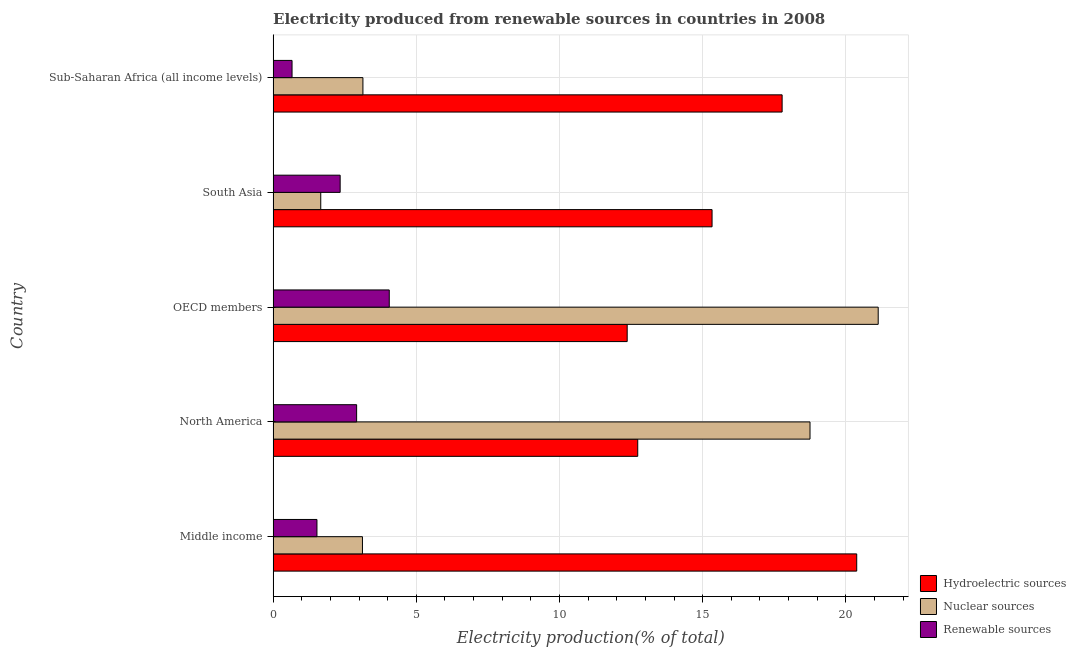How many different coloured bars are there?
Your answer should be very brief. 3. Are the number of bars on each tick of the Y-axis equal?
Offer a terse response. Yes. What is the percentage of electricity produced by nuclear sources in Sub-Saharan Africa (all income levels)?
Offer a terse response. 3.14. Across all countries, what is the maximum percentage of electricity produced by nuclear sources?
Keep it short and to the point. 21.13. Across all countries, what is the minimum percentage of electricity produced by renewable sources?
Offer a terse response. 0.66. What is the total percentage of electricity produced by renewable sources in the graph?
Provide a short and direct response. 11.51. What is the difference between the percentage of electricity produced by nuclear sources in Middle income and that in OECD members?
Your answer should be compact. -18.01. What is the difference between the percentage of electricity produced by nuclear sources in Middle income and the percentage of electricity produced by hydroelectric sources in Sub-Saharan Africa (all income levels)?
Your answer should be compact. -14.66. What is the average percentage of electricity produced by renewable sources per country?
Ensure brevity in your answer.  2.3. What is the difference between the percentage of electricity produced by hydroelectric sources and percentage of electricity produced by renewable sources in Middle income?
Give a very brief answer. 18.85. What is the ratio of the percentage of electricity produced by nuclear sources in North America to that in Sub-Saharan Africa (all income levels)?
Your response must be concise. 5.98. Is the percentage of electricity produced by nuclear sources in OECD members less than that in Sub-Saharan Africa (all income levels)?
Offer a terse response. No. Is the difference between the percentage of electricity produced by nuclear sources in OECD members and Sub-Saharan Africa (all income levels) greater than the difference between the percentage of electricity produced by renewable sources in OECD members and Sub-Saharan Africa (all income levels)?
Offer a very short reply. Yes. What is the difference between the highest and the second highest percentage of electricity produced by nuclear sources?
Provide a succinct answer. 2.38. Is the sum of the percentage of electricity produced by nuclear sources in Middle income and South Asia greater than the maximum percentage of electricity produced by hydroelectric sources across all countries?
Keep it short and to the point. No. What does the 1st bar from the top in Sub-Saharan Africa (all income levels) represents?
Give a very brief answer. Renewable sources. What does the 1st bar from the bottom in South Asia represents?
Provide a short and direct response. Hydroelectric sources. Is it the case that in every country, the sum of the percentage of electricity produced by hydroelectric sources and percentage of electricity produced by nuclear sources is greater than the percentage of electricity produced by renewable sources?
Offer a terse response. Yes. How many bars are there?
Provide a succinct answer. 15. What is the difference between two consecutive major ticks on the X-axis?
Provide a short and direct response. 5. Are the values on the major ticks of X-axis written in scientific E-notation?
Provide a succinct answer. No. Does the graph contain any zero values?
Provide a succinct answer. No. How many legend labels are there?
Make the answer very short. 3. How are the legend labels stacked?
Offer a terse response. Vertical. What is the title of the graph?
Your answer should be very brief. Electricity produced from renewable sources in countries in 2008. What is the label or title of the X-axis?
Make the answer very short. Electricity production(% of total). What is the label or title of the Y-axis?
Make the answer very short. Country. What is the Electricity production(% of total) in Hydroelectric sources in Middle income?
Your answer should be compact. 20.38. What is the Electricity production(% of total) of Nuclear sources in Middle income?
Offer a very short reply. 3.12. What is the Electricity production(% of total) of Renewable sources in Middle income?
Ensure brevity in your answer.  1.53. What is the Electricity production(% of total) of Hydroelectric sources in North America?
Offer a terse response. 12.73. What is the Electricity production(% of total) in Nuclear sources in North America?
Your response must be concise. 18.75. What is the Electricity production(% of total) of Renewable sources in North America?
Provide a short and direct response. 2.92. What is the Electricity production(% of total) of Hydroelectric sources in OECD members?
Offer a very short reply. 12.37. What is the Electricity production(% of total) of Nuclear sources in OECD members?
Your response must be concise. 21.13. What is the Electricity production(% of total) of Renewable sources in OECD members?
Offer a terse response. 4.06. What is the Electricity production(% of total) in Hydroelectric sources in South Asia?
Your answer should be very brief. 15.33. What is the Electricity production(% of total) of Nuclear sources in South Asia?
Offer a terse response. 1.66. What is the Electricity production(% of total) in Renewable sources in South Asia?
Your response must be concise. 2.34. What is the Electricity production(% of total) in Hydroelectric sources in Sub-Saharan Africa (all income levels)?
Your answer should be very brief. 17.78. What is the Electricity production(% of total) of Nuclear sources in Sub-Saharan Africa (all income levels)?
Make the answer very short. 3.14. What is the Electricity production(% of total) of Renewable sources in Sub-Saharan Africa (all income levels)?
Your answer should be compact. 0.66. Across all countries, what is the maximum Electricity production(% of total) of Hydroelectric sources?
Ensure brevity in your answer.  20.38. Across all countries, what is the maximum Electricity production(% of total) in Nuclear sources?
Your answer should be compact. 21.13. Across all countries, what is the maximum Electricity production(% of total) of Renewable sources?
Your answer should be compact. 4.06. Across all countries, what is the minimum Electricity production(% of total) in Hydroelectric sources?
Your answer should be compact. 12.37. Across all countries, what is the minimum Electricity production(% of total) in Nuclear sources?
Your response must be concise. 1.66. Across all countries, what is the minimum Electricity production(% of total) of Renewable sources?
Your response must be concise. 0.66. What is the total Electricity production(% of total) of Hydroelectric sources in the graph?
Keep it short and to the point. 78.58. What is the total Electricity production(% of total) in Nuclear sources in the graph?
Make the answer very short. 47.8. What is the total Electricity production(% of total) of Renewable sources in the graph?
Ensure brevity in your answer.  11.51. What is the difference between the Electricity production(% of total) in Hydroelectric sources in Middle income and that in North America?
Provide a short and direct response. 7.65. What is the difference between the Electricity production(% of total) in Nuclear sources in Middle income and that in North America?
Keep it short and to the point. -15.63. What is the difference between the Electricity production(% of total) in Renewable sources in Middle income and that in North America?
Make the answer very short. -1.39. What is the difference between the Electricity production(% of total) of Hydroelectric sources in Middle income and that in OECD members?
Offer a terse response. 8.02. What is the difference between the Electricity production(% of total) of Nuclear sources in Middle income and that in OECD members?
Provide a succinct answer. -18.01. What is the difference between the Electricity production(% of total) in Renewable sources in Middle income and that in OECD members?
Ensure brevity in your answer.  -2.53. What is the difference between the Electricity production(% of total) of Hydroelectric sources in Middle income and that in South Asia?
Ensure brevity in your answer.  5.05. What is the difference between the Electricity production(% of total) of Nuclear sources in Middle income and that in South Asia?
Offer a very short reply. 1.46. What is the difference between the Electricity production(% of total) in Renewable sources in Middle income and that in South Asia?
Your answer should be compact. -0.81. What is the difference between the Electricity production(% of total) in Hydroelectric sources in Middle income and that in Sub-Saharan Africa (all income levels)?
Ensure brevity in your answer.  2.6. What is the difference between the Electricity production(% of total) of Nuclear sources in Middle income and that in Sub-Saharan Africa (all income levels)?
Provide a short and direct response. -0.02. What is the difference between the Electricity production(% of total) of Renewable sources in Middle income and that in Sub-Saharan Africa (all income levels)?
Provide a short and direct response. 0.87. What is the difference between the Electricity production(% of total) of Hydroelectric sources in North America and that in OECD members?
Your answer should be very brief. 0.37. What is the difference between the Electricity production(% of total) of Nuclear sources in North America and that in OECD members?
Give a very brief answer. -2.38. What is the difference between the Electricity production(% of total) in Renewable sources in North America and that in OECD members?
Offer a terse response. -1.14. What is the difference between the Electricity production(% of total) of Hydroelectric sources in North America and that in South Asia?
Ensure brevity in your answer.  -2.6. What is the difference between the Electricity production(% of total) of Nuclear sources in North America and that in South Asia?
Your answer should be compact. 17.09. What is the difference between the Electricity production(% of total) of Renewable sources in North America and that in South Asia?
Your answer should be very brief. 0.58. What is the difference between the Electricity production(% of total) of Hydroelectric sources in North America and that in Sub-Saharan Africa (all income levels)?
Provide a succinct answer. -5.04. What is the difference between the Electricity production(% of total) of Nuclear sources in North America and that in Sub-Saharan Africa (all income levels)?
Keep it short and to the point. 15.61. What is the difference between the Electricity production(% of total) in Renewable sources in North America and that in Sub-Saharan Africa (all income levels)?
Your answer should be compact. 2.26. What is the difference between the Electricity production(% of total) of Hydroelectric sources in OECD members and that in South Asia?
Offer a very short reply. -2.96. What is the difference between the Electricity production(% of total) in Nuclear sources in OECD members and that in South Asia?
Your response must be concise. 19.47. What is the difference between the Electricity production(% of total) in Renewable sources in OECD members and that in South Asia?
Give a very brief answer. 1.72. What is the difference between the Electricity production(% of total) in Hydroelectric sources in OECD members and that in Sub-Saharan Africa (all income levels)?
Your response must be concise. -5.41. What is the difference between the Electricity production(% of total) of Nuclear sources in OECD members and that in Sub-Saharan Africa (all income levels)?
Your answer should be very brief. 18. What is the difference between the Electricity production(% of total) of Renewable sources in OECD members and that in Sub-Saharan Africa (all income levels)?
Your answer should be compact. 3.4. What is the difference between the Electricity production(% of total) of Hydroelectric sources in South Asia and that in Sub-Saharan Africa (all income levels)?
Offer a terse response. -2.45. What is the difference between the Electricity production(% of total) of Nuclear sources in South Asia and that in Sub-Saharan Africa (all income levels)?
Provide a succinct answer. -1.47. What is the difference between the Electricity production(% of total) of Renewable sources in South Asia and that in Sub-Saharan Africa (all income levels)?
Provide a short and direct response. 1.68. What is the difference between the Electricity production(% of total) of Hydroelectric sources in Middle income and the Electricity production(% of total) of Nuclear sources in North America?
Give a very brief answer. 1.63. What is the difference between the Electricity production(% of total) of Hydroelectric sources in Middle income and the Electricity production(% of total) of Renewable sources in North America?
Provide a succinct answer. 17.46. What is the difference between the Electricity production(% of total) of Nuclear sources in Middle income and the Electricity production(% of total) of Renewable sources in North America?
Offer a very short reply. 0.2. What is the difference between the Electricity production(% of total) in Hydroelectric sources in Middle income and the Electricity production(% of total) in Nuclear sources in OECD members?
Offer a very short reply. -0.75. What is the difference between the Electricity production(% of total) in Hydroelectric sources in Middle income and the Electricity production(% of total) in Renewable sources in OECD members?
Provide a short and direct response. 16.32. What is the difference between the Electricity production(% of total) of Nuclear sources in Middle income and the Electricity production(% of total) of Renewable sources in OECD members?
Give a very brief answer. -0.94. What is the difference between the Electricity production(% of total) of Hydroelectric sources in Middle income and the Electricity production(% of total) of Nuclear sources in South Asia?
Your answer should be compact. 18.72. What is the difference between the Electricity production(% of total) of Hydroelectric sources in Middle income and the Electricity production(% of total) of Renewable sources in South Asia?
Ensure brevity in your answer.  18.04. What is the difference between the Electricity production(% of total) in Nuclear sources in Middle income and the Electricity production(% of total) in Renewable sources in South Asia?
Your answer should be compact. 0.78. What is the difference between the Electricity production(% of total) of Hydroelectric sources in Middle income and the Electricity production(% of total) of Nuclear sources in Sub-Saharan Africa (all income levels)?
Ensure brevity in your answer.  17.24. What is the difference between the Electricity production(% of total) in Hydroelectric sources in Middle income and the Electricity production(% of total) in Renewable sources in Sub-Saharan Africa (all income levels)?
Your response must be concise. 19.72. What is the difference between the Electricity production(% of total) in Nuclear sources in Middle income and the Electricity production(% of total) in Renewable sources in Sub-Saharan Africa (all income levels)?
Offer a terse response. 2.46. What is the difference between the Electricity production(% of total) of Hydroelectric sources in North America and the Electricity production(% of total) of Nuclear sources in OECD members?
Keep it short and to the point. -8.4. What is the difference between the Electricity production(% of total) of Hydroelectric sources in North America and the Electricity production(% of total) of Renewable sources in OECD members?
Ensure brevity in your answer.  8.68. What is the difference between the Electricity production(% of total) in Nuclear sources in North America and the Electricity production(% of total) in Renewable sources in OECD members?
Your answer should be very brief. 14.69. What is the difference between the Electricity production(% of total) in Hydroelectric sources in North America and the Electricity production(% of total) in Nuclear sources in South Asia?
Give a very brief answer. 11.07. What is the difference between the Electricity production(% of total) in Hydroelectric sources in North America and the Electricity production(% of total) in Renewable sources in South Asia?
Your answer should be compact. 10.39. What is the difference between the Electricity production(% of total) of Nuclear sources in North America and the Electricity production(% of total) of Renewable sources in South Asia?
Provide a short and direct response. 16.41. What is the difference between the Electricity production(% of total) of Hydroelectric sources in North America and the Electricity production(% of total) of Nuclear sources in Sub-Saharan Africa (all income levels)?
Your response must be concise. 9.6. What is the difference between the Electricity production(% of total) in Hydroelectric sources in North America and the Electricity production(% of total) in Renewable sources in Sub-Saharan Africa (all income levels)?
Offer a terse response. 12.07. What is the difference between the Electricity production(% of total) of Nuclear sources in North America and the Electricity production(% of total) of Renewable sources in Sub-Saharan Africa (all income levels)?
Offer a very short reply. 18.09. What is the difference between the Electricity production(% of total) in Hydroelectric sources in OECD members and the Electricity production(% of total) in Nuclear sources in South Asia?
Your answer should be compact. 10.7. What is the difference between the Electricity production(% of total) of Hydroelectric sources in OECD members and the Electricity production(% of total) of Renewable sources in South Asia?
Offer a terse response. 10.02. What is the difference between the Electricity production(% of total) in Nuclear sources in OECD members and the Electricity production(% of total) in Renewable sources in South Asia?
Provide a short and direct response. 18.79. What is the difference between the Electricity production(% of total) in Hydroelectric sources in OECD members and the Electricity production(% of total) in Nuclear sources in Sub-Saharan Africa (all income levels)?
Your answer should be compact. 9.23. What is the difference between the Electricity production(% of total) of Hydroelectric sources in OECD members and the Electricity production(% of total) of Renewable sources in Sub-Saharan Africa (all income levels)?
Your response must be concise. 11.7. What is the difference between the Electricity production(% of total) in Nuclear sources in OECD members and the Electricity production(% of total) in Renewable sources in Sub-Saharan Africa (all income levels)?
Provide a short and direct response. 20.47. What is the difference between the Electricity production(% of total) in Hydroelectric sources in South Asia and the Electricity production(% of total) in Nuclear sources in Sub-Saharan Africa (all income levels)?
Offer a terse response. 12.19. What is the difference between the Electricity production(% of total) in Hydroelectric sources in South Asia and the Electricity production(% of total) in Renewable sources in Sub-Saharan Africa (all income levels)?
Your response must be concise. 14.67. What is the difference between the Electricity production(% of total) in Nuclear sources in South Asia and the Electricity production(% of total) in Renewable sources in Sub-Saharan Africa (all income levels)?
Offer a very short reply. 1. What is the average Electricity production(% of total) in Hydroelectric sources per country?
Ensure brevity in your answer.  15.72. What is the average Electricity production(% of total) in Nuclear sources per country?
Your answer should be compact. 9.56. What is the average Electricity production(% of total) of Renewable sources per country?
Keep it short and to the point. 2.3. What is the difference between the Electricity production(% of total) of Hydroelectric sources and Electricity production(% of total) of Nuclear sources in Middle income?
Offer a very short reply. 17.26. What is the difference between the Electricity production(% of total) in Hydroelectric sources and Electricity production(% of total) in Renewable sources in Middle income?
Make the answer very short. 18.85. What is the difference between the Electricity production(% of total) in Nuclear sources and Electricity production(% of total) in Renewable sources in Middle income?
Your response must be concise. 1.59. What is the difference between the Electricity production(% of total) in Hydroelectric sources and Electricity production(% of total) in Nuclear sources in North America?
Offer a very short reply. -6.02. What is the difference between the Electricity production(% of total) of Hydroelectric sources and Electricity production(% of total) of Renewable sources in North America?
Offer a terse response. 9.82. What is the difference between the Electricity production(% of total) in Nuclear sources and Electricity production(% of total) in Renewable sources in North America?
Offer a very short reply. 15.83. What is the difference between the Electricity production(% of total) of Hydroelectric sources and Electricity production(% of total) of Nuclear sources in OECD members?
Your answer should be compact. -8.77. What is the difference between the Electricity production(% of total) of Hydroelectric sources and Electricity production(% of total) of Renewable sources in OECD members?
Offer a very short reply. 8.31. What is the difference between the Electricity production(% of total) of Nuclear sources and Electricity production(% of total) of Renewable sources in OECD members?
Offer a very short reply. 17.08. What is the difference between the Electricity production(% of total) in Hydroelectric sources and Electricity production(% of total) in Nuclear sources in South Asia?
Make the answer very short. 13.67. What is the difference between the Electricity production(% of total) in Hydroelectric sources and Electricity production(% of total) in Renewable sources in South Asia?
Ensure brevity in your answer.  12.99. What is the difference between the Electricity production(% of total) in Nuclear sources and Electricity production(% of total) in Renewable sources in South Asia?
Make the answer very short. -0.68. What is the difference between the Electricity production(% of total) of Hydroelectric sources and Electricity production(% of total) of Nuclear sources in Sub-Saharan Africa (all income levels)?
Keep it short and to the point. 14.64. What is the difference between the Electricity production(% of total) of Hydroelectric sources and Electricity production(% of total) of Renewable sources in Sub-Saharan Africa (all income levels)?
Provide a succinct answer. 17.11. What is the difference between the Electricity production(% of total) of Nuclear sources and Electricity production(% of total) of Renewable sources in Sub-Saharan Africa (all income levels)?
Offer a terse response. 2.48. What is the ratio of the Electricity production(% of total) in Hydroelectric sources in Middle income to that in North America?
Make the answer very short. 1.6. What is the ratio of the Electricity production(% of total) of Nuclear sources in Middle income to that in North America?
Provide a succinct answer. 0.17. What is the ratio of the Electricity production(% of total) in Renewable sources in Middle income to that in North America?
Offer a terse response. 0.53. What is the ratio of the Electricity production(% of total) of Hydroelectric sources in Middle income to that in OECD members?
Provide a short and direct response. 1.65. What is the ratio of the Electricity production(% of total) in Nuclear sources in Middle income to that in OECD members?
Your response must be concise. 0.15. What is the ratio of the Electricity production(% of total) in Renewable sources in Middle income to that in OECD members?
Make the answer very short. 0.38. What is the ratio of the Electricity production(% of total) of Hydroelectric sources in Middle income to that in South Asia?
Make the answer very short. 1.33. What is the ratio of the Electricity production(% of total) of Nuclear sources in Middle income to that in South Asia?
Your answer should be very brief. 1.88. What is the ratio of the Electricity production(% of total) of Renewable sources in Middle income to that in South Asia?
Your answer should be very brief. 0.65. What is the ratio of the Electricity production(% of total) in Hydroelectric sources in Middle income to that in Sub-Saharan Africa (all income levels)?
Provide a succinct answer. 1.15. What is the ratio of the Electricity production(% of total) of Nuclear sources in Middle income to that in Sub-Saharan Africa (all income levels)?
Ensure brevity in your answer.  0.99. What is the ratio of the Electricity production(% of total) of Renewable sources in Middle income to that in Sub-Saharan Africa (all income levels)?
Your response must be concise. 2.32. What is the ratio of the Electricity production(% of total) of Hydroelectric sources in North America to that in OECD members?
Your answer should be very brief. 1.03. What is the ratio of the Electricity production(% of total) of Nuclear sources in North America to that in OECD members?
Your response must be concise. 0.89. What is the ratio of the Electricity production(% of total) in Renewable sources in North America to that in OECD members?
Provide a short and direct response. 0.72. What is the ratio of the Electricity production(% of total) of Hydroelectric sources in North America to that in South Asia?
Offer a terse response. 0.83. What is the ratio of the Electricity production(% of total) of Nuclear sources in North America to that in South Asia?
Your answer should be compact. 11.27. What is the ratio of the Electricity production(% of total) in Renewable sources in North America to that in South Asia?
Provide a short and direct response. 1.25. What is the ratio of the Electricity production(% of total) of Hydroelectric sources in North America to that in Sub-Saharan Africa (all income levels)?
Ensure brevity in your answer.  0.72. What is the ratio of the Electricity production(% of total) in Nuclear sources in North America to that in Sub-Saharan Africa (all income levels)?
Your answer should be compact. 5.98. What is the ratio of the Electricity production(% of total) in Renewable sources in North America to that in Sub-Saharan Africa (all income levels)?
Make the answer very short. 4.41. What is the ratio of the Electricity production(% of total) in Hydroelectric sources in OECD members to that in South Asia?
Provide a succinct answer. 0.81. What is the ratio of the Electricity production(% of total) in Nuclear sources in OECD members to that in South Asia?
Ensure brevity in your answer.  12.7. What is the ratio of the Electricity production(% of total) in Renewable sources in OECD members to that in South Asia?
Provide a short and direct response. 1.73. What is the ratio of the Electricity production(% of total) in Hydroelectric sources in OECD members to that in Sub-Saharan Africa (all income levels)?
Keep it short and to the point. 0.7. What is the ratio of the Electricity production(% of total) in Nuclear sources in OECD members to that in Sub-Saharan Africa (all income levels)?
Give a very brief answer. 6.74. What is the ratio of the Electricity production(% of total) in Renewable sources in OECD members to that in Sub-Saharan Africa (all income levels)?
Give a very brief answer. 6.14. What is the ratio of the Electricity production(% of total) of Hydroelectric sources in South Asia to that in Sub-Saharan Africa (all income levels)?
Provide a succinct answer. 0.86. What is the ratio of the Electricity production(% of total) in Nuclear sources in South Asia to that in Sub-Saharan Africa (all income levels)?
Give a very brief answer. 0.53. What is the ratio of the Electricity production(% of total) of Renewable sources in South Asia to that in Sub-Saharan Africa (all income levels)?
Your answer should be compact. 3.54. What is the difference between the highest and the second highest Electricity production(% of total) in Hydroelectric sources?
Ensure brevity in your answer.  2.6. What is the difference between the highest and the second highest Electricity production(% of total) of Nuclear sources?
Offer a very short reply. 2.38. What is the difference between the highest and the second highest Electricity production(% of total) of Renewable sources?
Provide a succinct answer. 1.14. What is the difference between the highest and the lowest Electricity production(% of total) in Hydroelectric sources?
Provide a short and direct response. 8.02. What is the difference between the highest and the lowest Electricity production(% of total) in Nuclear sources?
Your answer should be compact. 19.47. What is the difference between the highest and the lowest Electricity production(% of total) in Renewable sources?
Ensure brevity in your answer.  3.4. 